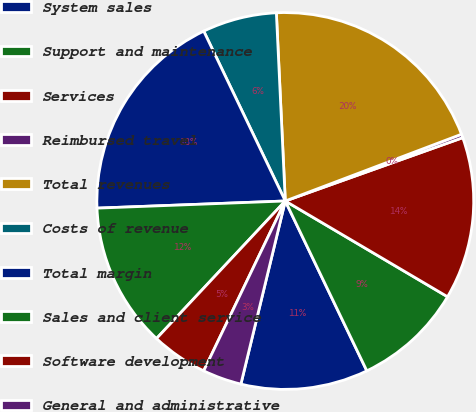Convert chart to OTSL. <chart><loc_0><loc_0><loc_500><loc_500><pie_chart><fcel>System sales<fcel>Support and maintenance<fcel>Services<fcel>Reimbursed travel<fcel>Total revenues<fcel>Costs of revenue<fcel>Total margin<fcel>Sales and client service<fcel>Software development<fcel>General and administrative<nl><fcel>10.91%<fcel>9.39%<fcel>13.94%<fcel>0.31%<fcel>19.99%<fcel>6.37%<fcel>18.48%<fcel>12.42%<fcel>4.85%<fcel>3.34%<nl></chart> 